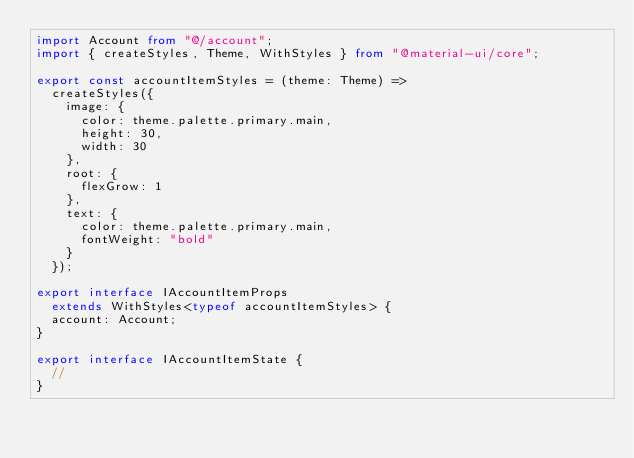Convert code to text. <code><loc_0><loc_0><loc_500><loc_500><_TypeScript_>import Account from "@/account";
import { createStyles, Theme, WithStyles } from "@material-ui/core";

export const accountItemStyles = (theme: Theme) =>
  createStyles({
    image: {
      color: theme.palette.primary.main,
      height: 30,
      width: 30
    },
    root: {
      flexGrow: 1
    },
    text: {
      color: theme.palette.primary.main,
      fontWeight: "bold"
    }
  });

export interface IAccountItemProps
  extends WithStyles<typeof accountItemStyles> {
  account: Account;
}

export interface IAccountItemState {
  //
}
</code> 